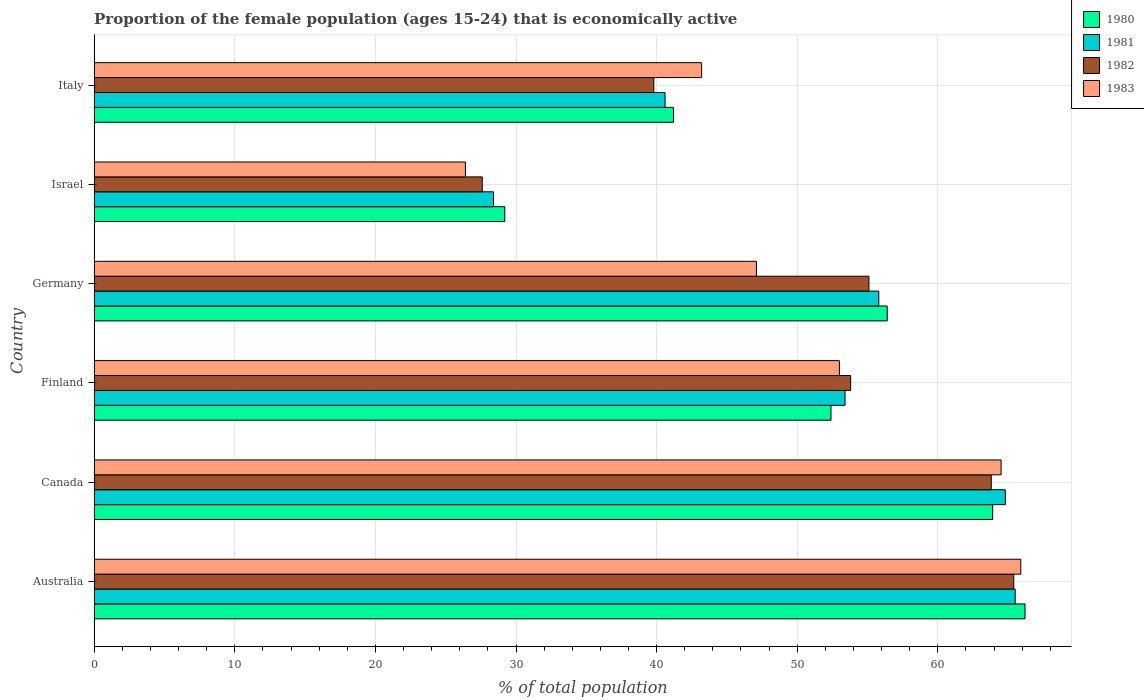How many different coloured bars are there?
Keep it short and to the point. 4. How many groups of bars are there?
Offer a terse response. 6. How many bars are there on the 3rd tick from the top?
Provide a short and direct response. 4. In how many cases, is the number of bars for a given country not equal to the number of legend labels?
Provide a succinct answer. 0. What is the proportion of the female population that is economically active in 1981 in Germany?
Provide a short and direct response. 55.8. Across all countries, what is the maximum proportion of the female population that is economically active in 1981?
Ensure brevity in your answer.  65.5. Across all countries, what is the minimum proportion of the female population that is economically active in 1980?
Your answer should be very brief. 29.2. What is the total proportion of the female population that is economically active in 1980 in the graph?
Keep it short and to the point. 309.3. What is the difference between the proportion of the female population that is economically active in 1980 in Israel and that in Italy?
Make the answer very short. -12. What is the difference between the proportion of the female population that is economically active in 1983 in Germany and the proportion of the female population that is economically active in 1980 in Canada?
Your response must be concise. -16.8. What is the average proportion of the female population that is economically active in 1981 per country?
Keep it short and to the point. 51.42. What is the difference between the proportion of the female population that is economically active in 1980 and proportion of the female population that is economically active in 1981 in Canada?
Offer a terse response. -0.9. What is the ratio of the proportion of the female population that is economically active in 1981 in Germany to that in Italy?
Keep it short and to the point. 1.37. Is the difference between the proportion of the female population that is economically active in 1980 in Australia and Finland greater than the difference between the proportion of the female population that is economically active in 1981 in Australia and Finland?
Offer a very short reply. Yes. What is the difference between the highest and the second highest proportion of the female population that is economically active in 1980?
Make the answer very short. 2.3. What is the difference between the highest and the lowest proportion of the female population that is economically active in 1981?
Provide a succinct answer. 37.1. In how many countries, is the proportion of the female population that is economically active in 1980 greater than the average proportion of the female population that is economically active in 1980 taken over all countries?
Provide a short and direct response. 4. Is the sum of the proportion of the female population that is economically active in 1983 in Australia and Finland greater than the maximum proportion of the female population that is economically active in 1982 across all countries?
Give a very brief answer. Yes. What does the 4th bar from the top in Finland represents?
Your answer should be compact. 1980. What does the 1st bar from the bottom in Germany represents?
Keep it short and to the point. 1980. Is it the case that in every country, the sum of the proportion of the female population that is economically active in 1982 and proportion of the female population that is economically active in 1980 is greater than the proportion of the female population that is economically active in 1983?
Provide a short and direct response. Yes. How many countries are there in the graph?
Provide a succinct answer. 6. What is the difference between two consecutive major ticks on the X-axis?
Provide a succinct answer. 10. Are the values on the major ticks of X-axis written in scientific E-notation?
Your answer should be compact. No. Does the graph contain any zero values?
Make the answer very short. No. Does the graph contain grids?
Ensure brevity in your answer.  Yes. How many legend labels are there?
Your response must be concise. 4. How are the legend labels stacked?
Give a very brief answer. Vertical. What is the title of the graph?
Give a very brief answer. Proportion of the female population (ages 15-24) that is economically active. Does "2000" appear as one of the legend labels in the graph?
Offer a very short reply. No. What is the label or title of the X-axis?
Your answer should be compact. % of total population. What is the label or title of the Y-axis?
Your response must be concise. Country. What is the % of total population in 1980 in Australia?
Ensure brevity in your answer.  66.2. What is the % of total population in 1981 in Australia?
Provide a short and direct response. 65.5. What is the % of total population of 1982 in Australia?
Provide a succinct answer. 65.4. What is the % of total population of 1983 in Australia?
Give a very brief answer. 65.9. What is the % of total population of 1980 in Canada?
Provide a short and direct response. 63.9. What is the % of total population in 1981 in Canada?
Your answer should be compact. 64.8. What is the % of total population of 1982 in Canada?
Ensure brevity in your answer.  63.8. What is the % of total population in 1983 in Canada?
Provide a succinct answer. 64.5. What is the % of total population in 1980 in Finland?
Offer a very short reply. 52.4. What is the % of total population of 1981 in Finland?
Your response must be concise. 53.4. What is the % of total population in 1982 in Finland?
Your response must be concise. 53.8. What is the % of total population of 1980 in Germany?
Provide a short and direct response. 56.4. What is the % of total population in 1981 in Germany?
Ensure brevity in your answer.  55.8. What is the % of total population of 1982 in Germany?
Your answer should be very brief. 55.1. What is the % of total population in 1983 in Germany?
Offer a terse response. 47.1. What is the % of total population of 1980 in Israel?
Give a very brief answer. 29.2. What is the % of total population in 1981 in Israel?
Keep it short and to the point. 28.4. What is the % of total population in 1982 in Israel?
Ensure brevity in your answer.  27.6. What is the % of total population of 1983 in Israel?
Provide a succinct answer. 26.4. What is the % of total population of 1980 in Italy?
Your response must be concise. 41.2. What is the % of total population in 1981 in Italy?
Ensure brevity in your answer.  40.6. What is the % of total population in 1982 in Italy?
Give a very brief answer. 39.8. What is the % of total population of 1983 in Italy?
Your response must be concise. 43.2. Across all countries, what is the maximum % of total population in 1980?
Your response must be concise. 66.2. Across all countries, what is the maximum % of total population of 1981?
Offer a terse response. 65.5. Across all countries, what is the maximum % of total population of 1982?
Provide a succinct answer. 65.4. Across all countries, what is the maximum % of total population of 1983?
Your answer should be very brief. 65.9. Across all countries, what is the minimum % of total population in 1980?
Make the answer very short. 29.2. Across all countries, what is the minimum % of total population of 1981?
Keep it short and to the point. 28.4. Across all countries, what is the minimum % of total population in 1982?
Keep it short and to the point. 27.6. Across all countries, what is the minimum % of total population of 1983?
Provide a short and direct response. 26.4. What is the total % of total population of 1980 in the graph?
Ensure brevity in your answer.  309.3. What is the total % of total population in 1981 in the graph?
Offer a very short reply. 308.5. What is the total % of total population in 1982 in the graph?
Provide a succinct answer. 305.5. What is the total % of total population in 1983 in the graph?
Keep it short and to the point. 300.1. What is the difference between the % of total population of 1980 in Australia and that in Canada?
Keep it short and to the point. 2.3. What is the difference between the % of total population in 1980 in Australia and that in Finland?
Provide a succinct answer. 13.8. What is the difference between the % of total population in 1981 in Australia and that in Finland?
Offer a terse response. 12.1. What is the difference between the % of total population in 1982 in Australia and that in Finland?
Make the answer very short. 11.6. What is the difference between the % of total population in 1980 in Australia and that in Germany?
Your answer should be compact. 9.8. What is the difference between the % of total population of 1982 in Australia and that in Germany?
Provide a succinct answer. 10.3. What is the difference between the % of total population in 1983 in Australia and that in Germany?
Keep it short and to the point. 18.8. What is the difference between the % of total population in 1981 in Australia and that in Israel?
Offer a terse response. 37.1. What is the difference between the % of total population of 1982 in Australia and that in Israel?
Offer a very short reply. 37.8. What is the difference between the % of total population in 1983 in Australia and that in Israel?
Your answer should be compact. 39.5. What is the difference between the % of total population of 1981 in Australia and that in Italy?
Offer a very short reply. 24.9. What is the difference between the % of total population of 1982 in Australia and that in Italy?
Your answer should be compact. 25.6. What is the difference between the % of total population of 1983 in Australia and that in Italy?
Keep it short and to the point. 22.7. What is the difference between the % of total population of 1980 in Canada and that in Finland?
Ensure brevity in your answer.  11.5. What is the difference between the % of total population of 1983 in Canada and that in Finland?
Keep it short and to the point. 11.5. What is the difference between the % of total population in 1982 in Canada and that in Germany?
Keep it short and to the point. 8.7. What is the difference between the % of total population of 1983 in Canada and that in Germany?
Your answer should be compact. 17.4. What is the difference between the % of total population of 1980 in Canada and that in Israel?
Offer a terse response. 34.7. What is the difference between the % of total population in 1981 in Canada and that in Israel?
Offer a terse response. 36.4. What is the difference between the % of total population of 1982 in Canada and that in Israel?
Make the answer very short. 36.2. What is the difference between the % of total population in 1983 in Canada and that in Israel?
Your response must be concise. 38.1. What is the difference between the % of total population of 1980 in Canada and that in Italy?
Offer a terse response. 22.7. What is the difference between the % of total population in 1981 in Canada and that in Italy?
Give a very brief answer. 24.2. What is the difference between the % of total population of 1983 in Canada and that in Italy?
Keep it short and to the point. 21.3. What is the difference between the % of total population in 1981 in Finland and that in Germany?
Keep it short and to the point. -2.4. What is the difference between the % of total population of 1982 in Finland and that in Germany?
Your answer should be compact. -1.3. What is the difference between the % of total population in 1983 in Finland and that in Germany?
Your response must be concise. 5.9. What is the difference between the % of total population in 1980 in Finland and that in Israel?
Your answer should be very brief. 23.2. What is the difference between the % of total population of 1981 in Finland and that in Israel?
Offer a terse response. 25. What is the difference between the % of total population in 1982 in Finland and that in Israel?
Give a very brief answer. 26.2. What is the difference between the % of total population in 1983 in Finland and that in Israel?
Provide a succinct answer. 26.6. What is the difference between the % of total population of 1980 in Finland and that in Italy?
Ensure brevity in your answer.  11.2. What is the difference between the % of total population in 1981 in Finland and that in Italy?
Your response must be concise. 12.8. What is the difference between the % of total population of 1980 in Germany and that in Israel?
Make the answer very short. 27.2. What is the difference between the % of total population in 1981 in Germany and that in Israel?
Ensure brevity in your answer.  27.4. What is the difference between the % of total population in 1982 in Germany and that in Israel?
Ensure brevity in your answer.  27.5. What is the difference between the % of total population in 1983 in Germany and that in Israel?
Your answer should be very brief. 20.7. What is the difference between the % of total population in 1980 in Germany and that in Italy?
Offer a very short reply. 15.2. What is the difference between the % of total population of 1981 in Germany and that in Italy?
Offer a very short reply. 15.2. What is the difference between the % of total population in 1980 in Israel and that in Italy?
Provide a short and direct response. -12. What is the difference between the % of total population of 1981 in Israel and that in Italy?
Offer a very short reply. -12.2. What is the difference between the % of total population of 1982 in Israel and that in Italy?
Offer a terse response. -12.2. What is the difference between the % of total population of 1983 in Israel and that in Italy?
Provide a short and direct response. -16.8. What is the difference between the % of total population in 1980 in Australia and the % of total population in 1981 in Canada?
Ensure brevity in your answer.  1.4. What is the difference between the % of total population in 1980 in Australia and the % of total population in 1982 in Canada?
Ensure brevity in your answer.  2.4. What is the difference between the % of total population of 1980 in Australia and the % of total population of 1982 in Finland?
Your answer should be very brief. 12.4. What is the difference between the % of total population in 1981 in Australia and the % of total population in 1982 in Finland?
Your answer should be compact. 11.7. What is the difference between the % of total population in 1981 in Australia and the % of total population in 1983 in Finland?
Your answer should be compact. 12.5. What is the difference between the % of total population in 1982 in Australia and the % of total population in 1983 in Finland?
Your answer should be compact. 12.4. What is the difference between the % of total population of 1980 in Australia and the % of total population of 1981 in Germany?
Your answer should be very brief. 10.4. What is the difference between the % of total population in 1980 in Australia and the % of total population in 1981 in Israel?
Keep it short and to the point. 37.8. What is the difference between the % of total population of 1980 in Australia and the % of total population of 1982 in Israel?
Provide a short and direct response. 38.6. What is the difference between the % of total population of 1980 in Australia and the % of total population of 1983 in Israel?
Your answer should be very brief. 39.8. What is the difference between the % of total population in 1981 in Australia and the % of total population in 1982 in Israel?
Offer a very short reply. 37.9. What is the difference between the % of total population of 1981 in Australia and the % of total population of 1983 in Israel?
Provide a short and direct response. 39.1. What is the difference between the % of total population in 1982 in Australia and the % of total population in 1983 in Israel?
Ensure brevity in your answer.  39. What is the difference between the % of total population in 1980 in Australia and the % of total population in 1981 in Italy?
Your answer should be very brief. 25.6. What is the difference between the % of total population of 1980 in Australia and the % of total population of 1982 in Italy?
Provide a succinct answer. 26.4. What is the difference between the % of total population in 1981 in Australia and the % of total population in 1982 in Italy?
Provide a succinct answer. 25.7. What is the difference between the % of total population of 1981 in Australia and the % of total population of 1983 in Italy?
Keep it short and to the point. 22.3. What is the difference between the % of total population of 1981 in Canada and the % of total population of 1982 in Finland?
Your answer should be very brief. 11. What is the difference between the % of total population of 1981 in Canada and the % of total population of 1983 in Finland?
Ensure brevity in your answer.  11.8. What is the difference between the % of total population in 1980 in Canada and the % of total population in 1981 in Germany?
Give a very brief answer. 8.1. What is the difference between the % of total population in 1980 in Canada and the % of total population in 1982 in Germany?
Offer a terse response. 8.8. What is the difference between the % of total population of 1980 in Canada and the % of total population of 1983 in Germany?
Provide a succinct answer. 16.8. What is the difference between the % of total population in 1981 in Canada and the % of total population in 1983 in Germany?
Keep it short and to the point. 17.7. What is the difference between the % of total population in 1980 in Canada and the % of total population in 1981 in Israel?
Give a very brief answer. 35.5. What is the difference between the % of total population of 1980 in Canada and the % of total population of 1982 in Israel?
Provide a short and direct response. 36.3. What is the difference between the % of total population in 1980 in Canada and the % of total population in 1983 in Israel?
Offer a very short reply. 37.5. What is the difference between the % of total population of 1981 in Canada and the % of total population of 1982 in Israel?
Provide a succinct answer. 37.2. What is the difference between the % of total population in 1981 in Canada and the % of total population in 1983 in Israel?
Your answer should be very brief. 38.4. What is the difference between the % of total population in 1982 in Canada and the % of total population in 1983 in Israel?
Your answer should be compact. 37.4. What is the difference between the % of total population in 1980 in Canada and the % of total population in 1981 in Italy?
Ensure brevity in your answer.  23.3. What is the difference between the % of total population of 1980 in Canada and the % of total population of 1982 in Italy?
Your answer should be very brief. 24.1. What is the difference between the % of total population in 1980 in Canada and the % of total population in 1983 in Italy?
Keep it short and to the point. 20.7. What is the difference between the % of total population in 1981 in Canada and the % of total population in 1982 in Italy?
Provide a short and direct response. 25. What is the difference between the % of total population of 1981 in Canada and the % of total population of 1983 in Italy?
Make the answer very short. 21.6. What is the difference between the % of total population of 1982 in Canada and the % of total population of 1983 in Italy?
Your answer should be very brief. 20.6. What is the difference between the % of total population in 1980 in Finland and the % of total population in 1981 in Germany?
Give a very brief answer. -3.4. What is the difference between the % of total population of 1980 in Finland and the % of total population of 1982 in Germany?
Ensure brevity in your answer.  -2.7. What is the difference between the % of total population in 1980 in Finland and the % of total population in 1983 in Germany?
Your answer should be compact. 5.3. What is the difference between the % of total population of 1980 in Finland and the % of total population of 1981 in Israel?
Provide a succinct answer. 24. What is the difference between the % of total population in 1980 in Finland and the % of total population in 1982 in Israel?
Make the answer very short. 24.8. What is the difference between the % of total population of 1980 in Finland and the % of total population of 1983 in Israel?
Provide a succinct answer. 26. What is the difference between the % of total population of 1981 in Finland and the % of total population of 1982 in Israel?
Keep it short and to the point. 25.8. What is the difference between the % of total population of 1981 in Finland and the % of total population of 1983 in Israel?
Make the answer very short. 27. What is the difference between the % of total population of 1982 in Finland and the % of total population of 1983 in Israel?
Provide a short and direct response. 27.4. What is the difference between the % of total population of 1980 in Finland and the % of total population of 1982 in Italy?
Make the answer very short. 12.6. What is the difference between the % of total population in 1981 in Finland and the % of total population in 1983 in Italy?
Give a very brief answer. 10.2. What is the difference between the % of total population in 1982 in Finland and the % of total population in 1983 in Italy?
Make the answer very short. 10.6. What is the difference between the % of total population of 1980 in Germany and the % of total population of 1981 in Israel?
Keep it short and to the point. 28. What is the difference between the % of total population in 1980 in Germany and the % of total population in 1982 in Israel?
Give a very brief answer. 28.8. What is the difference between the % of total population in 1981 in Germany and the % of total population in 1982 in Israel?
Your answer should be compact. 28.2. What is the difference between the % of total population of 1981 in Germany and the % of total population of 1983 in Israel?
Ensure brevity in your answer.  29.4. What is the difference between the % of total population of 1982 in Germany and the % of total population of 1983 in Israel?
Give a very brief answer. 28.7. What is the difference between the % of total population in 1980 in Germany and the % of total population in 1981 in Italy?
Provide a short and direct response. 15.8. What is the difference between the % of total population of 1980 in Germany and the % of total population of 1982 in Italy?
Your answer should be very brief. 16.6. What is the difference between the % of total population in 1980 in Germany and the % of total population in 1983 in Italy?
Your response must be concise. 13.2. What is the difference between the % of total population in 1981 in Germany and the % of total population in 1982 in Italy?
Offer a very short reply. 16. What is the difference between the % of total population in 1981 in Germany and the % of total population in 1983 in Italy?
Your answer should be compact. 12.6. What is the difference between the % of total population of 1980 in Israel and the % of total population of 1981 in Italy?
Offer a terse response. -11.4. What is the difference between the % of total population in 1980 in Israel and the % of total population in 1982 in Italy?
Your response must be concise. -10.6. What is the difference between the % of total population of 1981 in Israel and the % of total population of 1982 in Italy?
Your answer should be compact. -11.4. What is the difference between the % of total population in 1981 in Israel and the % of total population in 1983 in Italy?
Provide a short and direct response. -14.8. What is the difference between the % of total population of 1982 in Israel and the % of total population of 1983 in Italy?
Make the answer very short. -15.6. What is the average % of total population in 1980 per country?
Provide a succinct answer. 51.55. What is the average % of total population of 1981 per country?
Offer a terse response. 51.42. What is the average % of total population in 1982 per country?
Give a very brief answer. 50.92. What is the average % of total population of 1983 per country?
Offer a very short reply. 50.02. What is the difference between the % of total population in 1980 and % of total population in 1982 in Australia?
Offer a terse response. 0.8. What is the difference between the % of total population in 1981 and % of total population in 1982 in Australia?
Keep it short and to the point. 0.1. What is the difference between the % of total population of 1981 and % of total population of 1983 in Australia?
Your answer should be very brief. -0.4. What is the difference between the % of total population of 1980 and % of total population of 1982 in Canada?
Your response must be concise. 0.1. What is the difference between the % of total population of 1980 and % of total population of 1983 in Canada?
Offer a terse response. -0.6. What is the difference between the % of total population in 1981 and % of total population in 1982 in Canada?
Ensure brevity in your answer.  1. What is the difference between the % of total population of 1981 and % of total population of 1983 in Canada?
Your answer should be very brief. 0.3. What is the difference between the % of total population of 1980 and % of total population of 1983 in Finland?
Give a very brief answer. -0.6. What is the difference between the % of total population of 1981 and % of total population of 1983 in Finland?
Offer a terse response. 0.4. What is the difference between the % of total population in 1982 and % of total population in 1983 in Finland?
Make the answer very short. 0.8. What is the difference between the % of total population of 1980 and % of total population of 1981 in Germany?
Provide a short and direct response. 0.6. What is the difference between the % of total population in 1982 and % of total population in 1983 in Germany?
Make the answer very short. 8. What is the difference between the % of total population in 1980 and % of total population in 1981 in Israel?
Your answer should be very brief. 0.8. What is the difference between the % of total population in 1980 and % of total population in 1982 in Israel?
Your answer should be compact. 1.6. What is the difference between the % of total population in 1981 and % of total population in 1983 in Israel?
Offer a terse response. 2. What is the difference between the % of total population in 1982 and % of total population in 1983 in Israel?
Ensure brevity in your answer.  1.2. What is the difference between the % of total population in 1980 and % of total population in 1981 in Italy?
Your answer should be compact. 0.6. What is the difference between the % of total population of 1982 and % of total population of 1983 in Italy?
Make the answer very short. -3.4. What is the ratio of the % of total population of 1980 in Australia to that in Canada?
Offer a terse response. 1.04. What is the ratio of the % of total population of 1981 in Australia to that in Canada?
Your answer should be very brief. 1.01. What is the ratio of the % of total population of 1982 in Australia to that in Canada?
Provide a short and direct response. 1.03. What is the ratio of the % of total population in 1983 in Australia to that in Canada?
Make the answer very short. 1.02. What is the ratio of the % of total population of 1980 in Australia to that in Finland?
Keep it short and to the point. 1.26. What is the ratio of the % of total population of 1981 in Australia to that in Finland?
Provide a short and direct response. 1.23. What is the ratio of the % of total population of 1982 in Australia to that in Finland?
Provide a succinct answer. 1.22. What is the ratio of the % of total population in 1983 in Australia to that in Finland?
Ensure brevity in your answer.  1.24. What is the ratio of the % of total population of 1980 in Australia to that in Germany?
Your answer should be compact. 1.17. What is the ratio of the % of total population of 1981 in Australia to that in Germany?
Your answer should be very brief. 1.17. What is the ratio of the % of total population of 1982 in Australia to that in Germany?
Ensure brevity in your answer.  1.19. What is the ratio of the % of total population of 1983 in Australia to that in Germany?
Your response must be concise. 1.4. What is the ratio of the % of total population of 1980 in Australia to that in Israel?
Offer a very short reply. 2.27. What is the ratio of the % of total population of 1981 in Australia to that in Israel?
Provide a succinct answer. 2.31. What is the ratio of the % of total population in 1982 in Australia to that in Israel?
Keep it short and to the point. 2.37. What is the ratio of the % of total population of 1983 in Australia to that in Israel?
Provide a succinct answer. 2.5. What is the ratio of the % of total population of 1980 in Australia to that in Italy?
Keep it short and to the point. 1.61. What is the ratio of the % of total population of 1981 in Australia to that in Italy?
Your response must be concise. 1.61. What is the ratio of the % of total population of 1982 in Australia to that in Italy?
Keep it short and to the point. 1.64. What is the ratio of the % of total population in 1983 in Australia to that in Italy?
Give a very brief answer. 1.53. What is the ratio of the % of total population in 1980 in Canada to that in Finland?
Provide a succinct answer. 1.22. What is the ratio of the % of total population of 1981 in Canada to that in Finland?
Your answer should be compact. 1.21. What is the ratio of the % of total population in 1982 in Canada to that in Finland?
Your response must be concise. 1.19. What is the ratio of the % of total population of 1983 in Canada to that in Finland?
Offer a terse response. 1.22. What is the ratio of the % of total population in 1980 in Canada to that in Germany?
Provide a short and direct response. 1.13. What is the ratio of the % of total population of 1981 in Canada to that in Germany?
Make the answer very short. 1.16. What is the ratio of the % of total population of 1982 in Canada to that in Germany?
Your answer should be very brief. 1.16. What is the ratio of the % of total population in 1983 in Canada to that in Germany?
Keep it short and to the point. 1.37. What is the ratio of the % of total population in 1980 in Canada to that in Israel?
Provide a succinct answer. 2.19. What is the ratio of the % of total population of 1981 in Canada to that in Israel?
Ensure brevity in your answer.  2.28. What is the ratio of the % of total population in 1982 in Canada to that in Israel?
Your answer should be very brief. 2.31. What is the ratio of the % of total population in 1983 in Canada to that in Israel?
Provide a short and direct response. 2.44. What is the ratio of the % of total population in 1980 in Canada to that in Italy?
Provide a succinct answer. 1.55. What is the ratio of the % of total population in 1981 in Canada to that in Italy?
Provide a short and direct response. 1.6. What is the ratio of the % of total population in 1982 in Canada to that in Italy?
Give a very brief answer. 1.6. What is the ratio of the % of total population of 1983 in Canada to that in Italy?
Ensure brevity in your answer.  1.49. What is the ratio of the % of total population in 1980 in Finland to that in Germany?
Give a very brief answer. 0.93. What is the ratio of the % of total population in 1981 in Finland to that in Germany?
Make the answer very short. 0.96. What is the ratio of the % of total population of 1982 in Finland to that in Germany?
Your answer should be compact. 0.98. What is the ratio of the % of total population in 1983 in Finland to that in Germany?
Provide a short and direct response. 1.13. What is the ratio of the % of total population of 1980 in Finland to that in Israel?
Your response must be concise. 1.79. What is the ratio of the % of total population in 1981 in Finland to that in Israel?
Provide a short and direct response. 1.88. What is the ratio of the % of total population of 1982 in Finland to that in Israel?
Your response must be concise. 1.95. What is the ratio of the % of total population in 1983 in Finland to that in Israel?
Keep it short and to the point. 2.01. What is the ratio of the % of total population of 1980 in Finland to that in Italy?
Give a very brief answer. 1.27. What is the ratio of the % of total population in 1981 in Finland to that in Italy?
Your answer should be very brief. 1.32. What is the ratio of the % of total population of 1982 in Finland to that in Italy?
Offer a terse response. 1.35. What is the ratio of the % of total population in 1983 in Finland to that in Italy?
Offer a very short reply. 1.23. What is the ratio of the % of total population in 1980 in Germany to that in Israel?
Give a very brief answer. 1.93. What is the ratio of the % of total population of 1981 in Germany to that in Israel?
Offer a very short reply. 1.96. What is the ratio of the % of total population of 1982 in Germany to that in Israel?
Your answer should be compact. 2. What is the ratio of the % of total population of 1983 in Germany to that in Israel?
Your answer should be very brief. 1.78. What is the ratio of the % of total population of 1980 in Germany to that in Italy?
Offer a terse response. 1.37. What is the ratio of the % of total population of 1981 in Germany to that in Italy?
Give a very brief answer. 1.37. What is the ratio of the % of total population of 1982 in Germany to that in Italy?
Give a very brief answer. 1.38. What is the ratio of the % of total population in 1983 in Germany to that in Italy?
Provide a succinct answer. 1.09. What is the ratio of the % of total population of 1980 in Israel to that in Italy?
Keep it short and to the point. 0.71. What is the ratio of the % of total population of 1981 in Israel to that in Italy?
Ensure brevity in your answer.  0.7. What is the ratio of the % of total population of 1982 in Israel to that in Italy?
Keep it short and to the point. 0.69. What is the ratio of the % of total population in 1983 in Israel to that in Italy?
Your answer should be very brief. 0.61. What is the difference between the highest and the second highest % of total population in 1980?
Ensure brevity in your answer.  2.3. What is the difference between the highest and the second highest % of total population of 1981?
Give a very brief answer. 0.7. What is the difference between the highest and the lowest % of total population of 1981?
Make the answer very short. 37.1. What is the difference between the highest and the lowest % of total population in 1982?
Make the answer very short. 37.8. What is the difference between the highest and the lowest % of total population of 1983?
Your response must be concise. 39.5. 